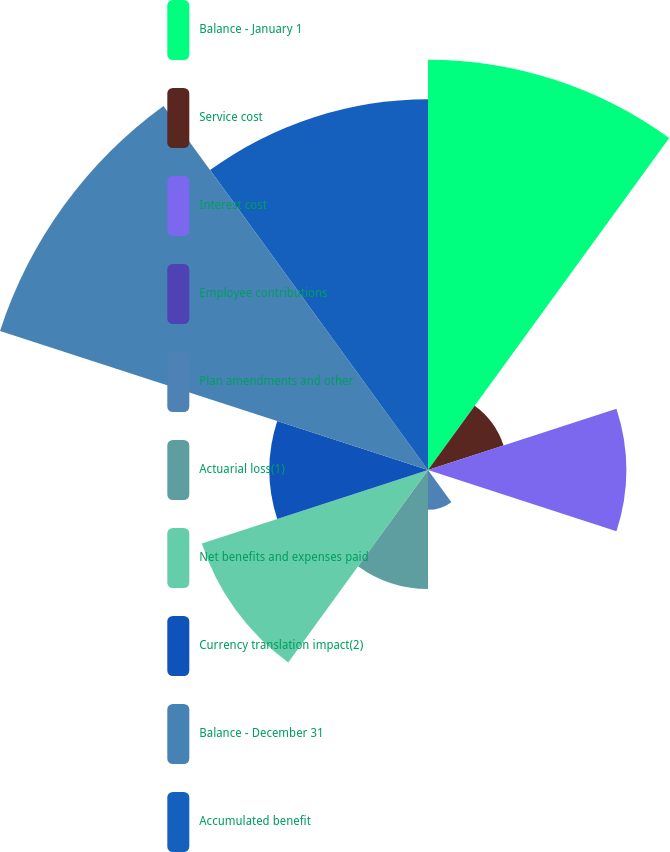<chart> <loc_0><loc_0><loc_500><loc_500><pie_chart><fcel>Balance - January 1<fcel>Service cost<fcel>Interest cost<fcel>Employee contributions<fcel>Plan amendments and other<fcel>Actuarial loss(1)<fcel>Net benefits and expenses paid<fcel>Currency translation impact(2)<fcel>Balance - December 31<fcel>Accumulated benefit<nl><fcel>19.88%<fcel>3.85%<fcel>9.6%<fcel>0.01%<fcel>1.93%<fcel>5.77%<fcel>11.52%<fcel>7.68%<fcel>21.8%<fcel>17.96%<nl></chart> 